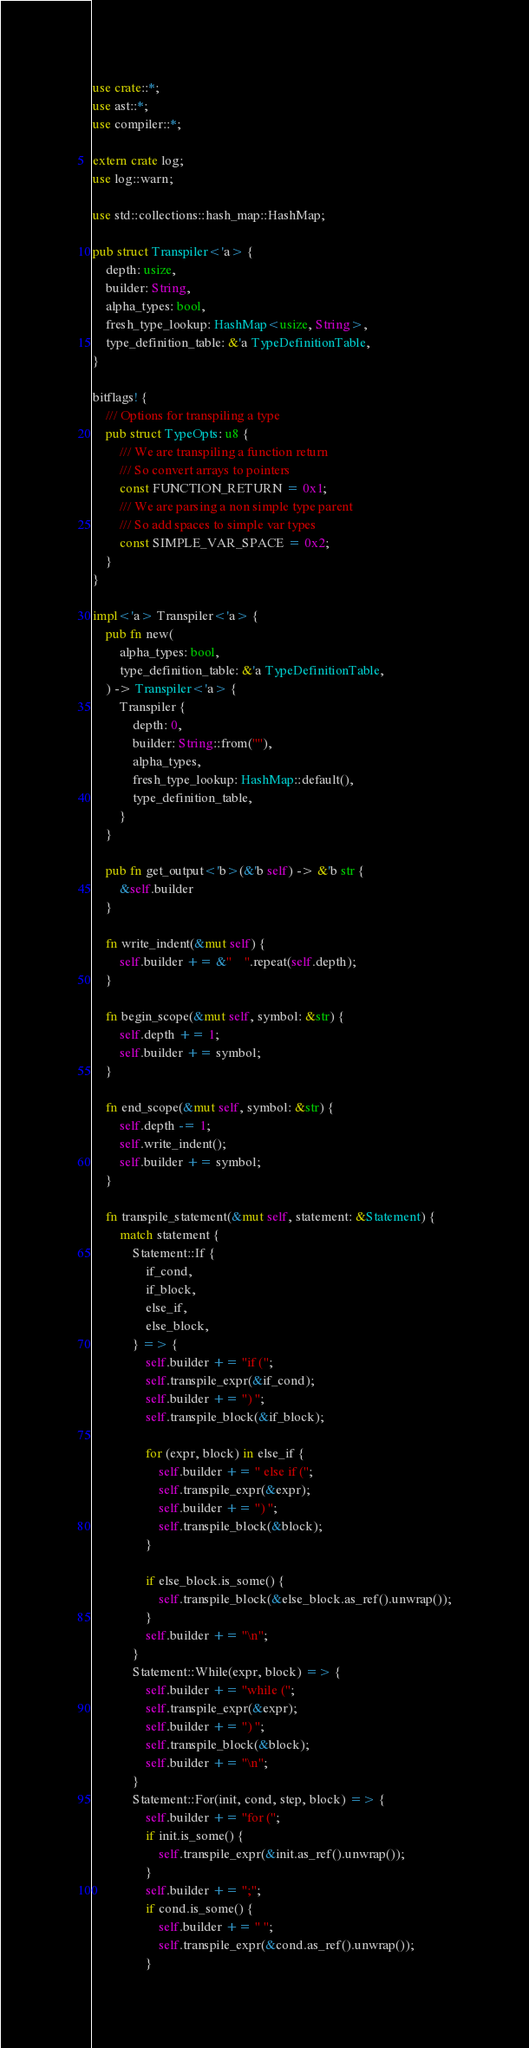Convert code to text. <code><loc_0><loc_0><loc_500><loc_500><_Rust_>use crate::*;
use ast::*;
use compiler::*;

extern crate log;
use log::warn;

use std::collections::hash_map::HashMap;

pub struct Transpiler<'a> {
    depth: usize,
    builder: String,
    alpha_types: bool,
    fresh_type_lookup: HashMap<usize, String>,
    type_definition_table: &'a TypeDefinitionTable,
}

bitflags! {
    /// Options for transpiling a type
    pub struct TypeOpts: u8 {
        /// We are transpiling a function return
        /// So convert arrays to pointers
        const FUNCTION_RETURN = 0x1;
        /// We are parsing a non simple type parent
        /// So add spaces to simple var types
        const SIMPLE_VAR_SPACE = 0x2;
    }
}

impl<'a> Transpiler<'a> {
    pub fn new(
        alpha_types: bool,
        type_definition_table: &'a TypeDefinitionTable,
    ) -> Transpiler<'a> {
        Transpiler {
            depth: 0,
            builder: String::from(""),
            alpha_types,
            fresh_type_lookup: HashMap::default(),
            type_definition_table,
        }
    }

    pub fn get_output<'b>(&'b self) -> &'b str {
        &self.builder
    }

    fn write_indent(&mut self) {
        self.builder += &"    ".repeat(self.depth);
    }

    fn begin_scope(&mut self, symbol: &str) {
        self.depth += 1;
        self.builder += symbol;
    }

    fn end_scope(&mut self, symbol: &str) {
        self.depth -= 1;
        self.write_indent();
        self.builder += symbol;
    }

    fn transpile_statement(&mut self, statement: &Statement) {
        match statement {
            Statement::If {
                if_cond,
                if_block,
                else_if,
                else_block,
            } => {
                self.builder += "if (";
                self.transpile_expr(&if_cond);
                self.builder += ") ";
                self.transpile_block(&if_block);

                for (expr, block) in else_if {
                    self.builder += " else if (";
                    self.transpile_expr(&expr);
                    self.builder += ") ";
                    self.transpile_block(&block);
                }

                if else_block.is_some() {
                    self.transpile_block(&else_block.as_ref().unwrap());
                }
                self.builder += "\n";
            }
            Statement::While(expr, block) => {
                self.builder += "while (";
                self.transpile_expr(&expr);
                self.builder += ") ";
                self.transpile_block(&block);
                self.builder += "\n";
            }
            Statement::For(init, cond, step, block) => {
                self.builder += "for (";
                if init.is_some() {
                    self.transpile_expr(&init.as_ref().unwrap());
                }
                self.builder += ";";
                if cond.is_some() {
                    self.builder += " ";
                    self.transpile_expr(&cond.as_ref().unwrap());
                }</code> 